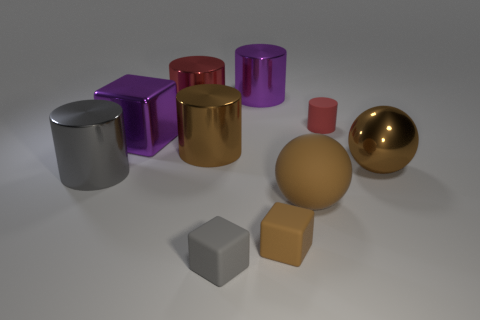What is the color of the metallic cylinder that is in front of the large purple block and right of the big red shiny cylinder?
Your answer should be compact. Brown. What number of tiny things are either purple cylinders or red matte objects?
Your answer should be very brief. 1. What is the size of the other matte object that is the same shape as the small brown matte thing?
Offer a terse response. Small. What shape is the red rubber thing?
Keep it short and to the point. Cylinder. Is the big red object made of the same material as the brown cylinder to the left of the small red rubber object?
Your answer should be compact. Yes. What number of matte things are big purple blocks or tiny red cylinders?
Your answer should be compact. 1. There is a block behind the big gray thing; what size is it?
Make the answer very short. Large. What size is the block that is made of the same material as the large red cylinder?
Offer a terse response. Large. What number of shiny things have the same color as the large matte ball?
Your response must be concise. 2. Are there any blue shiny objects?
Keep it short and to the point. No. 